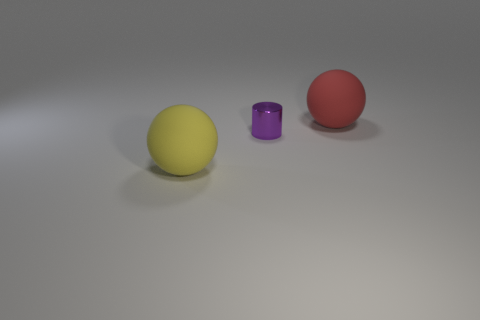How does the size of the tiny metal thing compare to the other objects? The tiny metal object, which appears to be a purple cylinder, is significantly smaller in both height and diameter than the two large spheres to its sides. 